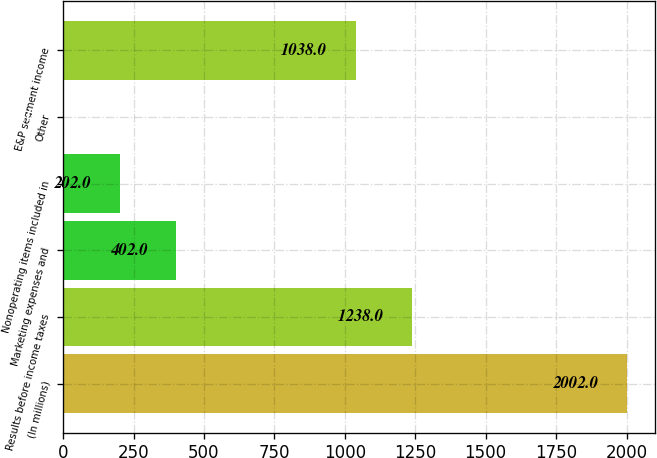Convert chart to OTSL. <chart><loc_0><loc_0><loc_500><loc_500><bar_chart><fcel>(In millions)<fcel>Results before income taxes<fcel>Marketing expenses and<fcel>Nonoperating items included in<fcel>Other<fcel>E&P segment income<nl><fcel>2002<fcel>1238<fcel>402<fcel>202<fcel>2<fcel>1038<nl></chart> 